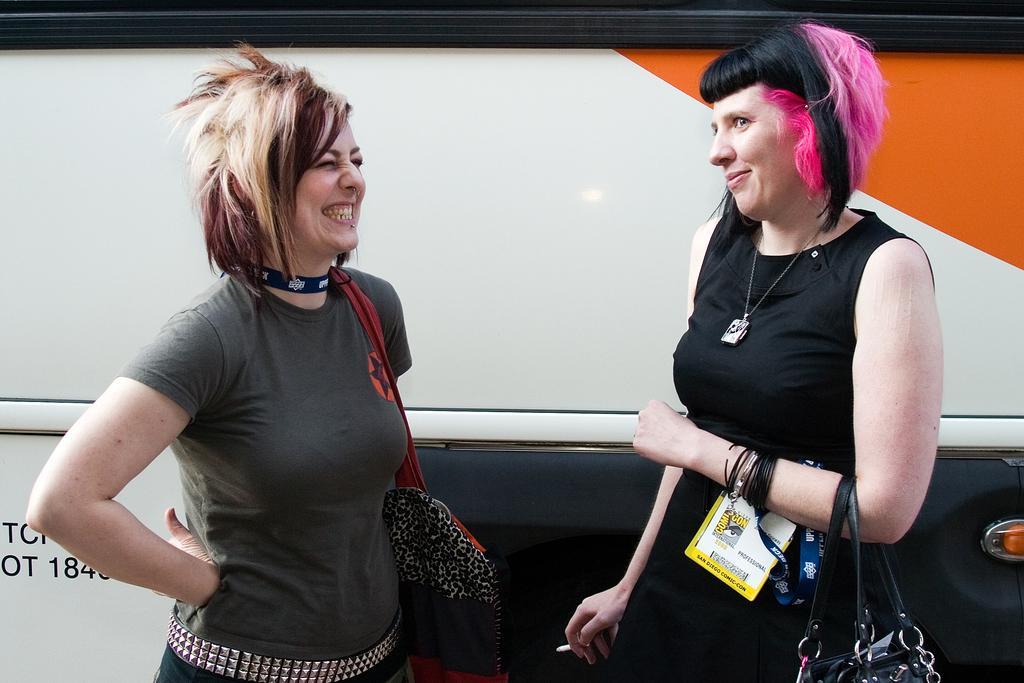Please provide a concise description of this image. In this image we can see two ladies standing beside a vehicle, two of them are holding bags, one lady is having cigarette, and access card in her hand. 